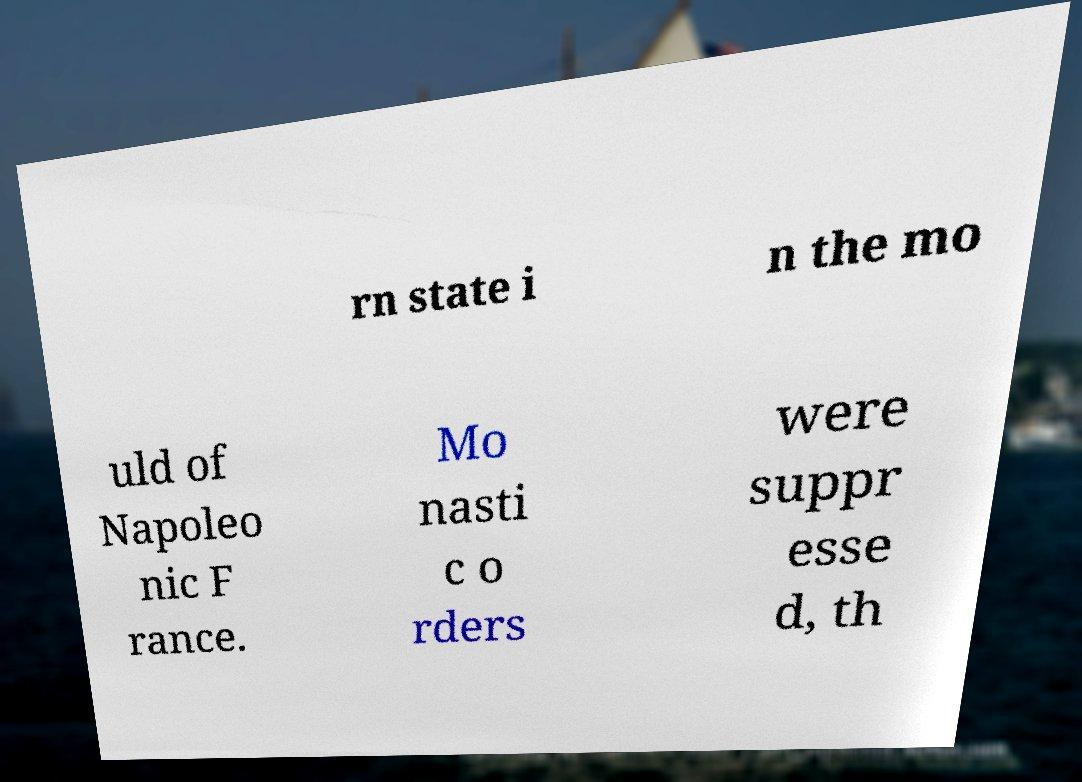Please identify and transcribe the text found in this image. rn state i n the mo uld of Napoleo nic F rance. Mo nasti c o rders were suppr esse d, th 